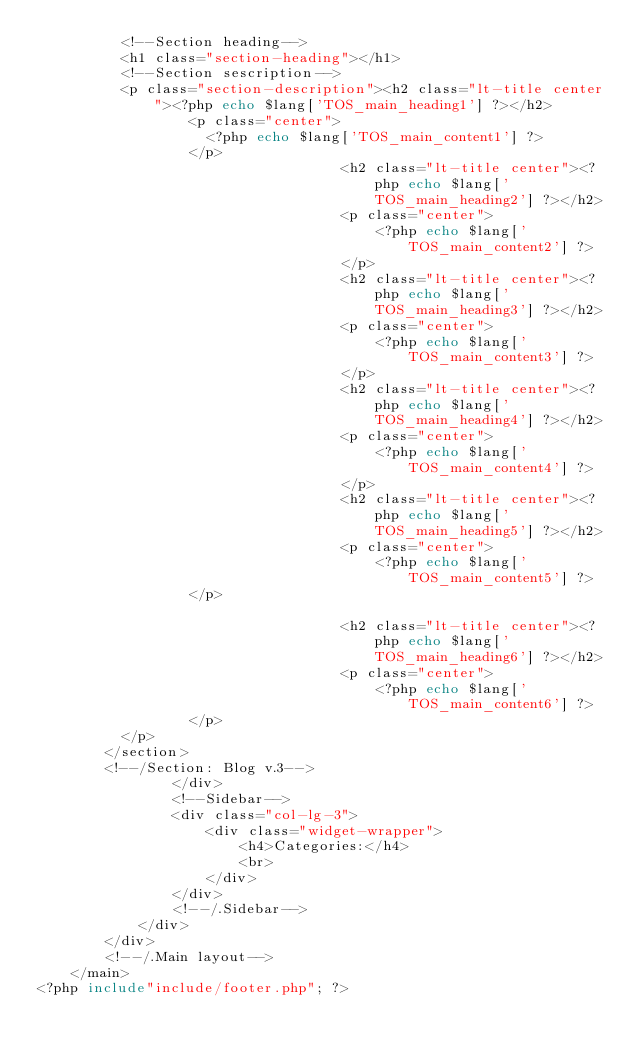<code> <loc_0><loc_0><loc_500><loc_500><_PHP_>					<!--Section heading-->
					<h1 class="section-heading"></h1>
					<!--Section sescription-->
					<p class="section-description"><h2 class="lt-title center"><?php echo $lang['TOS_main_heading1'] ?></h2>
									<p class="center">
										<?php echo $lang['TOS_main_content1'] ?>
									</p>
                                    <h2 class="lt-title center"><?php echo $lang['TOS_main_heading2'] ?></h2>
                                    <p class="center">
                                        <?php echo $lang['TOS_main_content2'] ?> 
                                    </p>
                                    <h2 class="lt-title center"><?php echo $lang['TOS_main_heading3'] ?></h2>
                                    <p class="center">
                                        <?php echo $lang['TOS_main_content3'] ?>
                                    </p>
                                    <h2 class="lt-title center"><?php echo $lang['TOS_main_heading4'] ?></h2>
                                    <p class="center">
                                        <?php echo $lang['TOS_main_content4'] ?>
                                    </p>
                                    <h2 class="lt-title center"><?php echo $lang['TOS_main_heading5'] ?></h2>
                                    <p class="center">
                                        <?php echo $lang['TOS_main_content5'] ?>
									</p>

                                    <h2 class="lt-title center"><?php echo $lang['TOS_main_heading6'] ?></h2>
                                    <p class="center">
                                        <?php echo $lang['TOS_main_content6'] ?>
									</p>
					</p>
				</section>
				<!--/Section: Blog v.3-->
                </div>
                <!--Sidebar-->
                <div class="col-lg-3">
                    <div class="widget-wrapper">
                        <h4>Categories:</h4>
                        <br>
                    </div>
                </div>
                <!--/.Sidebar-->
            </div>
        </div>
        <!--/.Main layout-->
    </main>
<?php include"include/footer.php"; ?></code> 